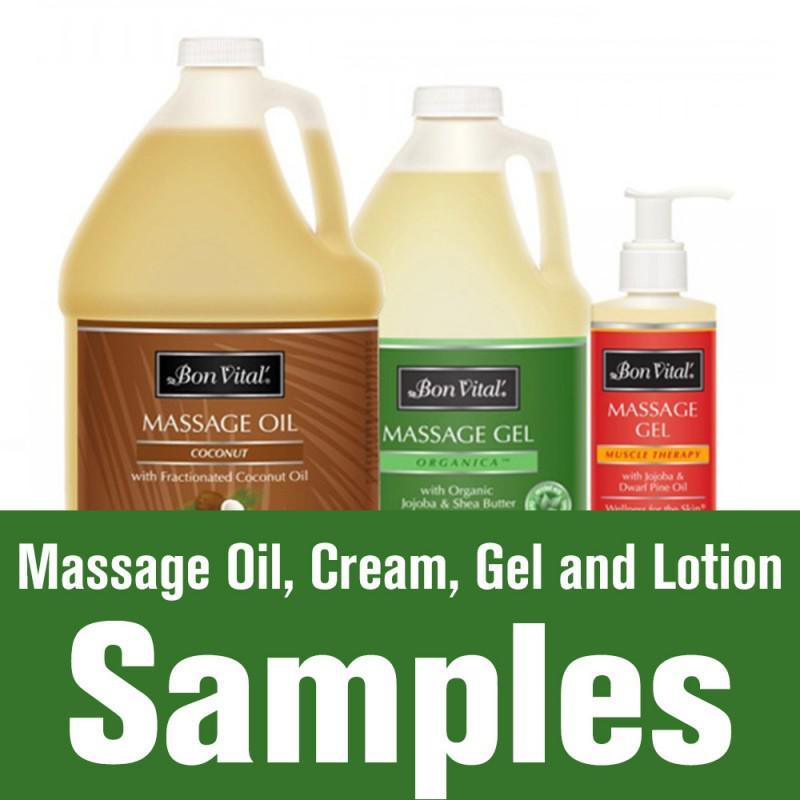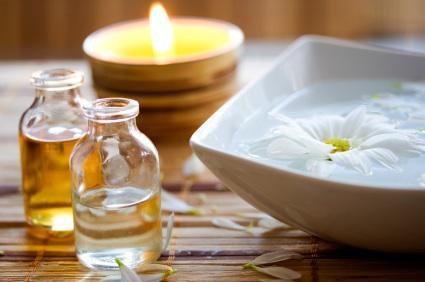The first image is the image on the left, the second image is the image on the right. Assess this claim about the two images: "There is a candle in one image.". Correct or not? Answer yes or no. Yes. 